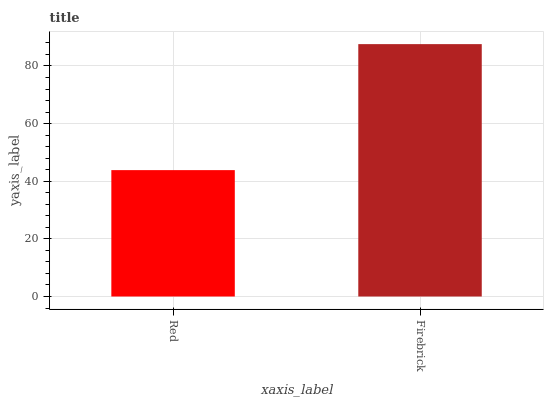Is Red the minimum?
Answer yes or no. Yes. Is Firebrick the maximum?
Answer yes or no. Yes. Is Firebrick the minimum?
Answer yes or no. No. Is Firebrick greater than Red?
Answer yes or no. Yes. Is Red less than Firebrick?
Answer yes or no. Yes. Is Red greater than Firebrick?
Answer yes or no. No. Is Firebrick less than Red?
Answer yes or no. No. Is Firebrick the high median?
Answer yes or no. Yes. Is Red the low median?
Answer yes or no. Yes. Is Red the high median?
Answer yes or no. No. Is Firebrick the low median?
Answer yes or no. No. 